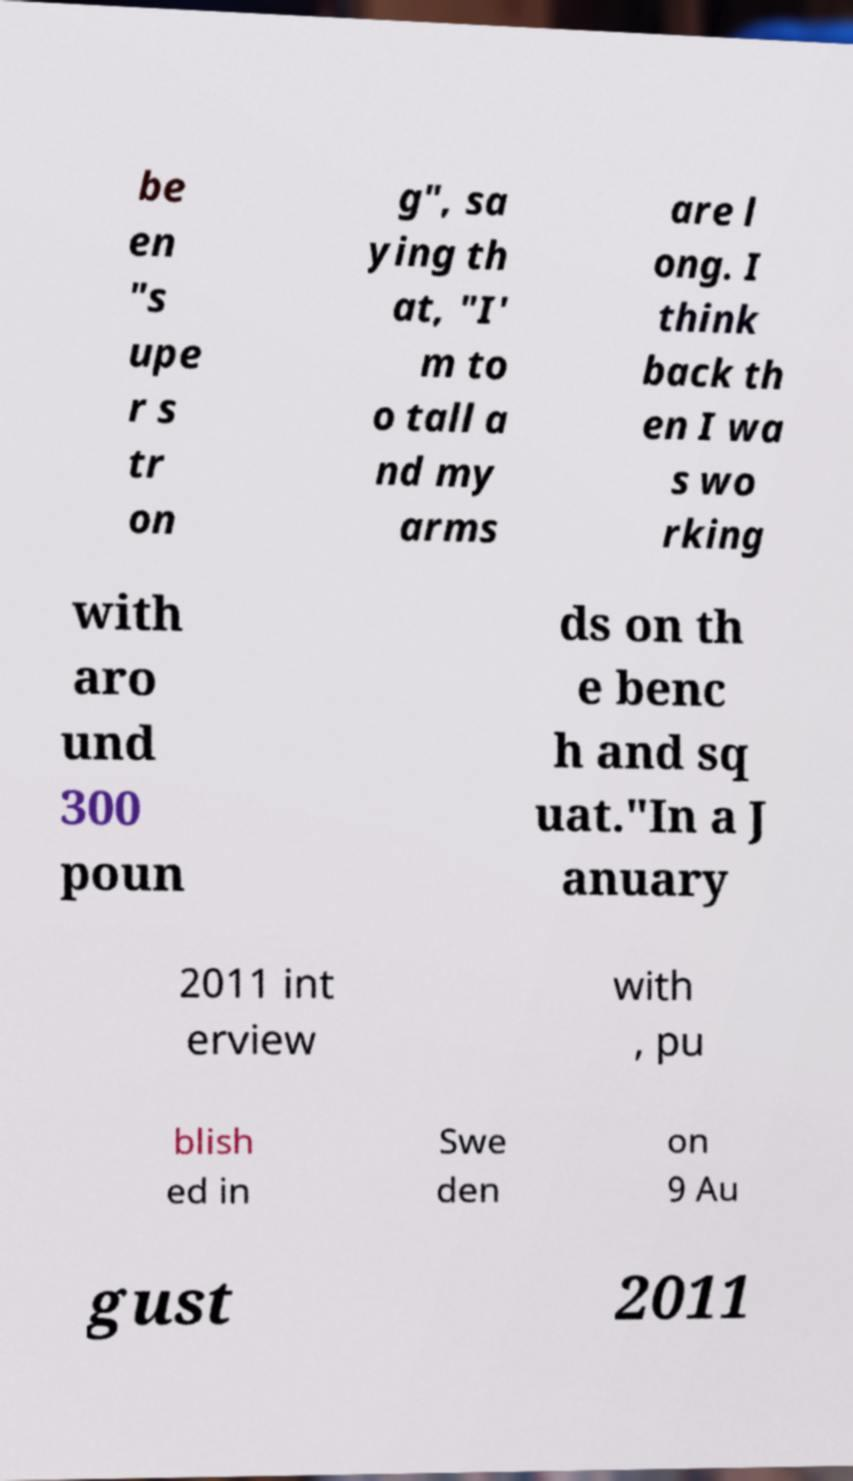Could you extract and type out the text from this image? be en "s upe r s tr on g", sa ying th at, "I' m to o tall a nd my arms are l ong. I think back th en I wa s wo rking with aro und 300 poun ds on th e benc h and sq uat."In a J anuary 2011 int erview with , pu blish ed in Swe den on 9 Au gust 2011 